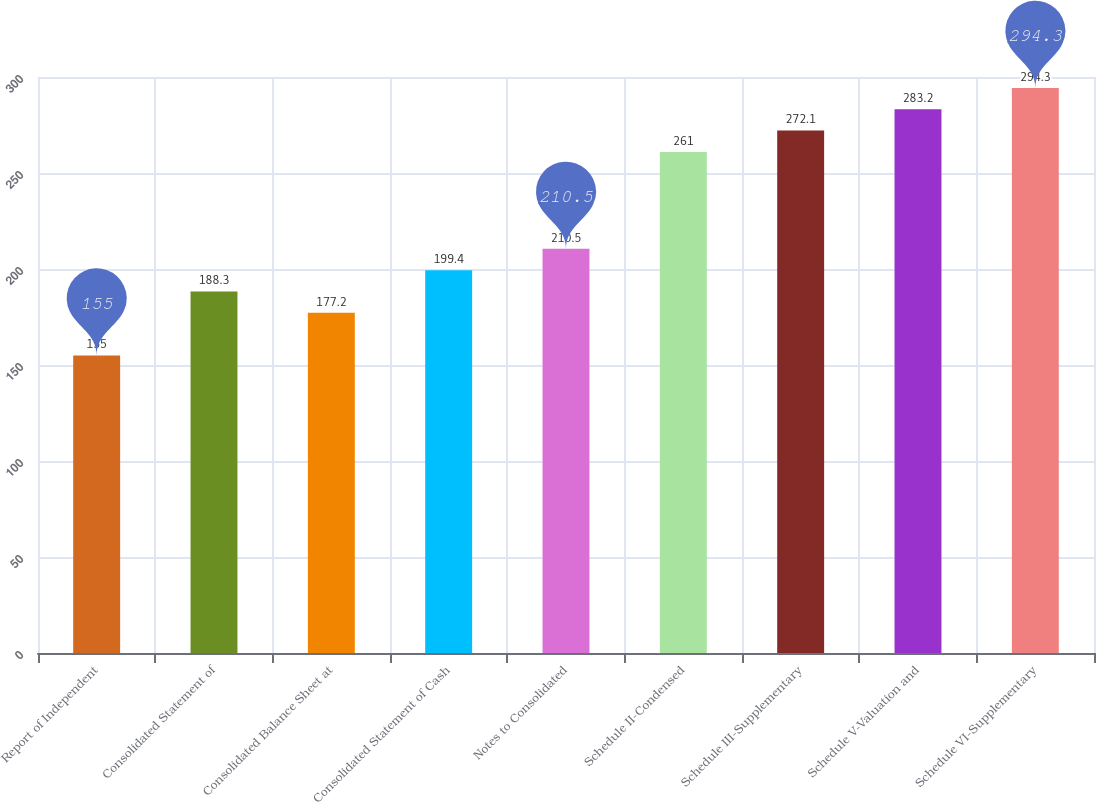Convert chart to OTSL. <chart><loc_0><loc_0><loc_500><loc_500><bar_chart><fcel>Report of Independent<fcel>Consolidated Statement of<fcel>Consolidated Balance Sheet at<fcel>Consolidated Statement of Cash<fcel>Notes to Consolidated<fcel>Schedule II-Condensed<fcel>Schedule III-Supplementary<fcel>Schedule V-Valuation and<fcel>Schedule VI-Supplementary<nl><fcel>155<fcel>188.3<fcel>177.2<fcel>199.4<fcel>210.5<fcel>261<fcel>272.1<fcel>283.2<fcel>294.3<nl></chart> 